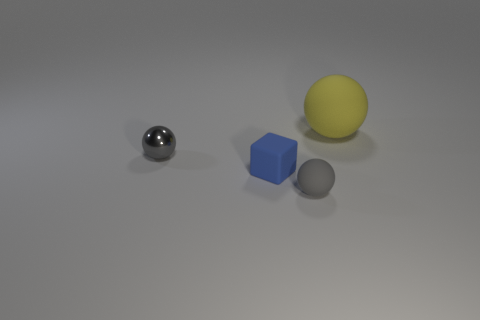Add 1 big blue cylinders. How many objects exist? 5 Subtract all gray metallic balls. How many balls are left? 2 Subtract all yellow spheres. How many spheres are left? 2 Subtract 1 blue cubes. How many objects are left? 3 Subtract all balls. How many objects are left? 1 Subtract all gray balls. Subtract all yellow blocks. How many balls are left? 1 Subtract all purple blocks. How many gray spheres are left? 2 Subtract all blue matte cubes. Subtract all gray things. How many objects are left? 1 Add 1 small gray matte objects. How many small gray matte objects are left? 2 Add 2 large yellow metal objects. How many large yellow metal objects exist? 2 